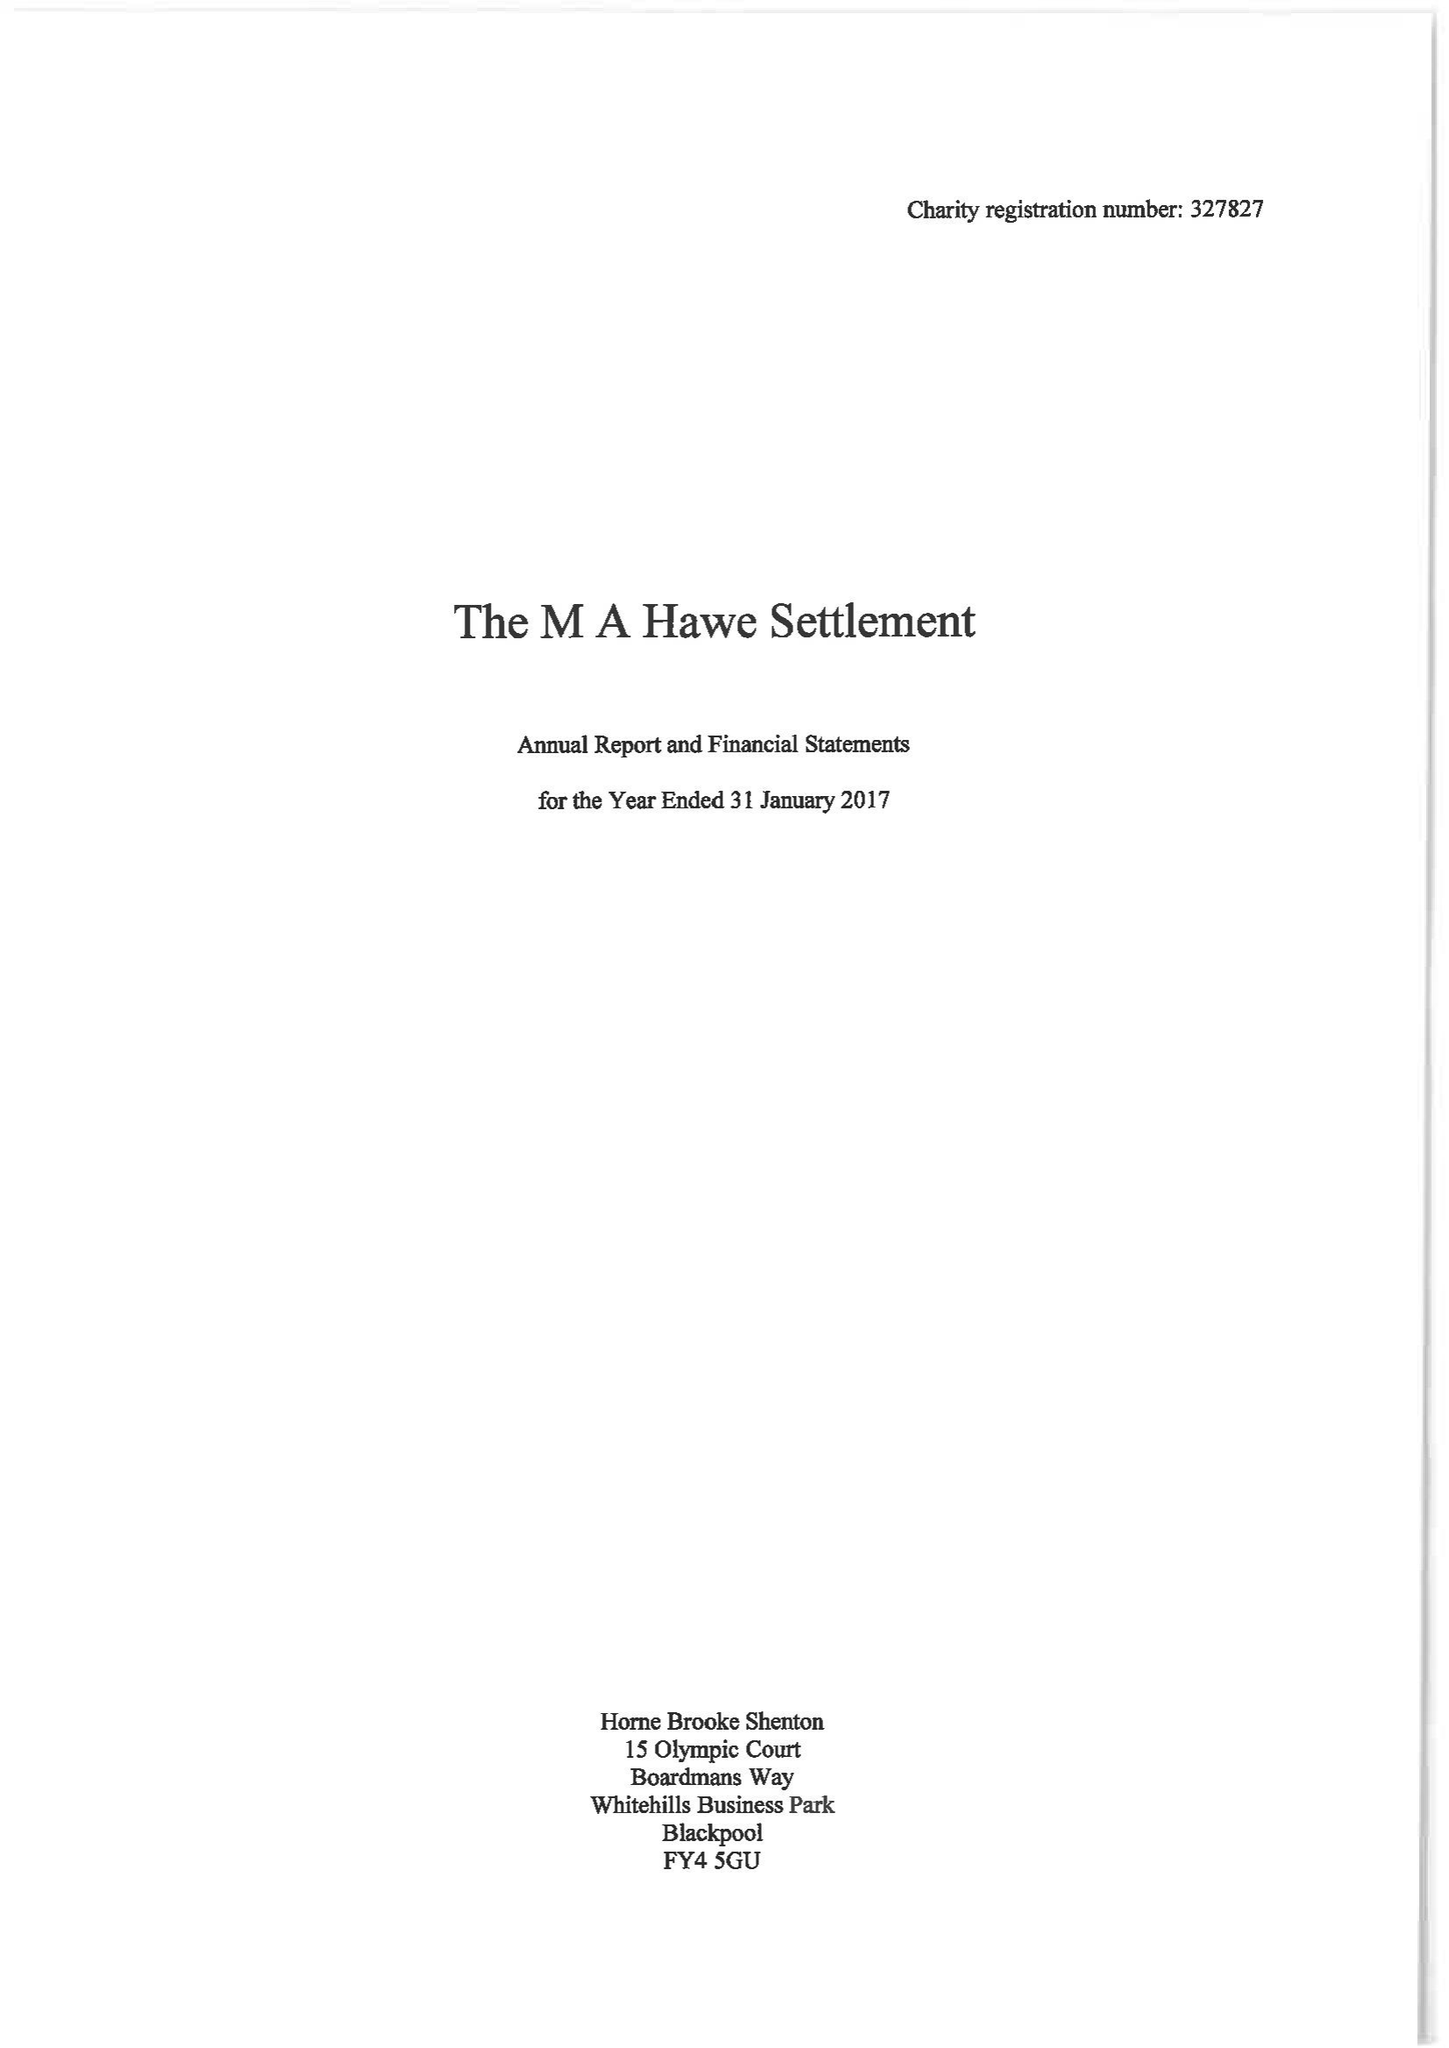What is the value for the charity_number?
Answer the question using a single word or phrase. 327827 